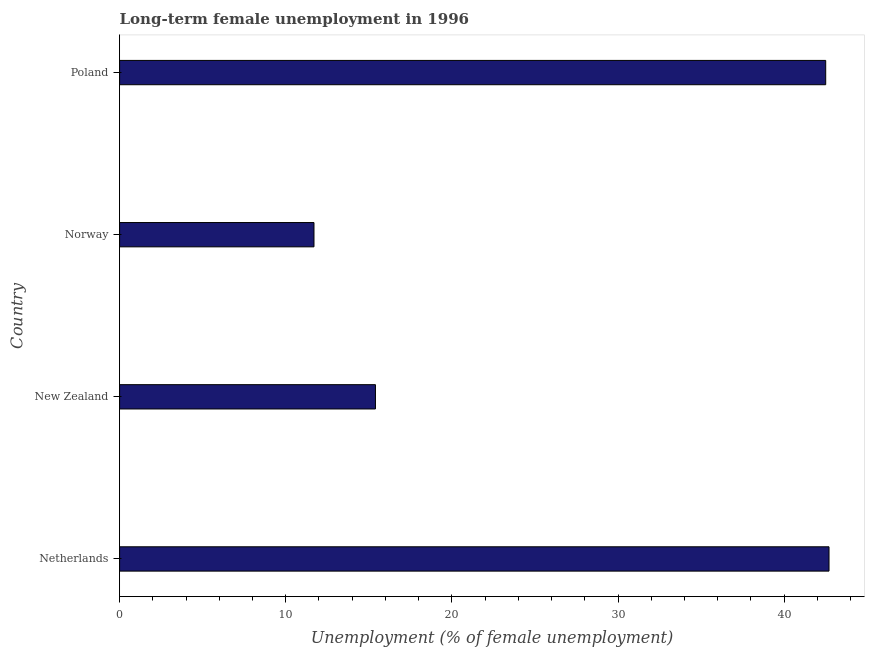Does the graph contain grids?
Ensure brevity in your answer.  No. What is the title of the graph?
Your answer should be very brief. Long-term female unemployment in 1996. What is the label or title of the X-axis?
Make the answer very short. Unemployment (% of female unemployment). What is the long-term female unemployment in Poland?
Ensure brevity in your answer.  42.5. Across all countries, what is the maximum long-term female unemployment?
Offer a terse response. 42.7. Across all countries, what is the minimum long-term female unemployment?
Your answer should be very brief. 11.7. In which country was the long-term female unemployment minimum?
Provide a short and direct response. Norway. What is the sum of the long-term female unemployment?
Offer a terse response. 112.3. What is the difference between the long-term female unemployment in Norway and Poland?
Your response must be concise. -30.8. What is the average long-term female unemployment per country?
Ensure brevity in your answer.  28.07. What is the median long-term female unemployment?
Ensure brevity in your answer.  28.95. What is the ratio of the long-term female unemployment in New Zealand to that in Norway?
Offer a very short reply. 1.32. Is the difference between the long-term female unemployment in New Zealand and Norway greater than the difference between any two countries?
Make the answer very short. No. What is the difference between the highest and the second highest long-term female unemployment?
Ensure brevity in your answer.  0.2. What is the difference between the highest and the lowest long-term female unemployment?
Your answer should be compact. 31. In how many countries, is the long-term female unemployment greater than the average long-term female unemployment taken over all countries?
Provide a short and direct response. 2. How many bars are there?
Your response must be concise. 4. How many countries are there in the graph?
Give a very brief answer. 4. What is the difference between two consecutive major ticks on the X-axis?
Keep it short and to the point. 10. What is the Unemployment (% of female unemployment) in Netherlands?
Keep it short and to the point. 42.7. What is the Unemployment (% of female unemployment) in New Zealand?
Make the answer very short. 15.4. What is the Unemployment (% of female unemployment) of Norway?
Keep it short and to the point. 11.7. What is the Unemployment (% of female unemployment) of Poland?
Ensure brevity in your answer.  42.5. What is the difference between the Unemployment (% of female unemployment) in Netherlands and New Zealand?
Provide a short and direct response. 27.3. What is the difference between the Unemployment (% of female unemployment) in Netherlands and Norway?
Provide a succinct answer. 31. What is the difference between the Unemployment (% of female unemployment) in New Zealand and Norway?
Your answer should be very brief. 3.7. What is the difference between the Unemployment (% of female unemployment) in New Zealand and Poland?
Provide a short and direct response. -27.1. What is the difference between the Unemployment (% of female unemployment) in Norway and Poland?
Ensure brevity in your answer.  -30.8. What is the ratio of the Unemployment (% of female unemployment) in Netherlands to that in New Zealand?
Provide a succinct answer. 2.77. What is the ratio of the Unemployment (% of female unemployment) in Netherlands to that in Norway?
Offer a terse response. 3.65. What is the ratio of the Unemployment (% of female unemployment) in New Zealand to that in Norway?
Provide a short and direct response. 1.32. What is the ratio of the Unemployment (% of female unemployment) in New Zealand to that in Poland?
Your response must be concise. 0.36. What is the ratio of the Unemployment (% of female unemployment) in Norway to that in Poland?
Ensure brevity in your answer.  0.28. 